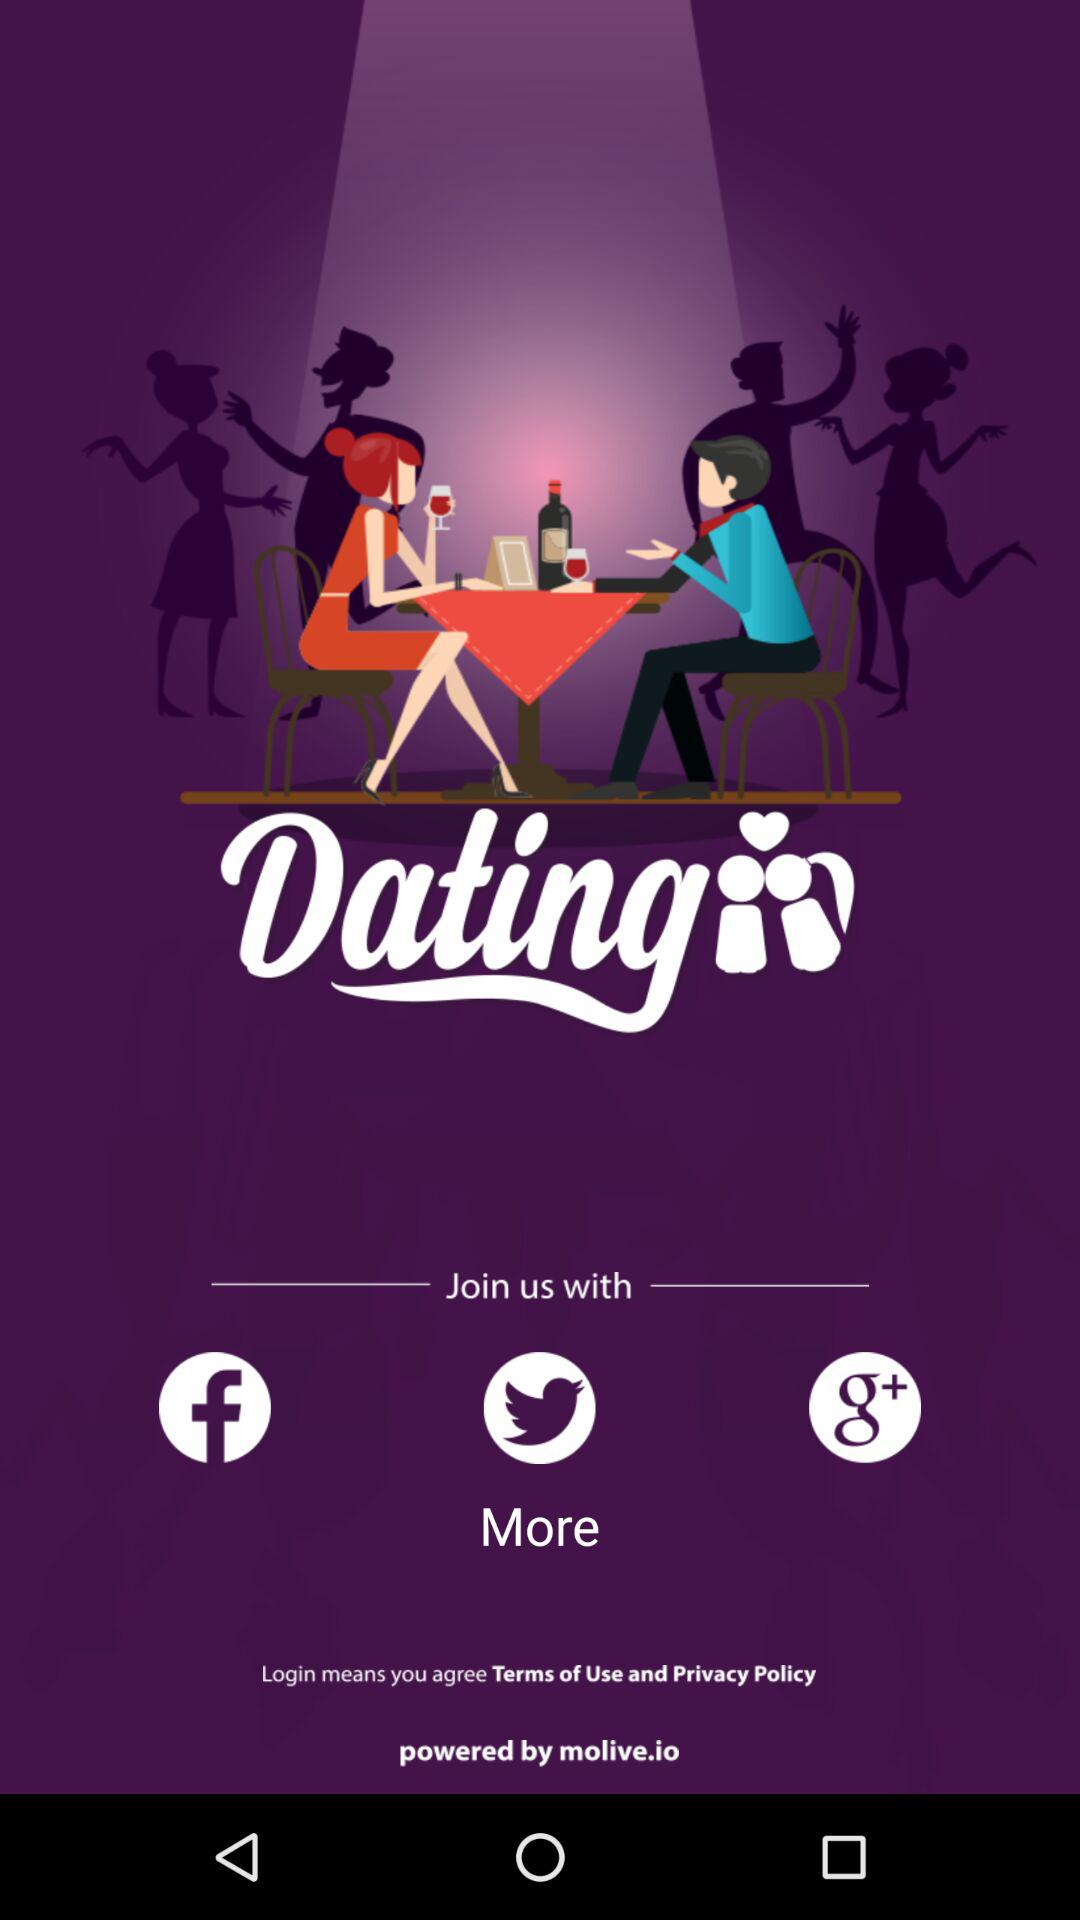Whom is the application powered by? The application is powered by "molive.io". 